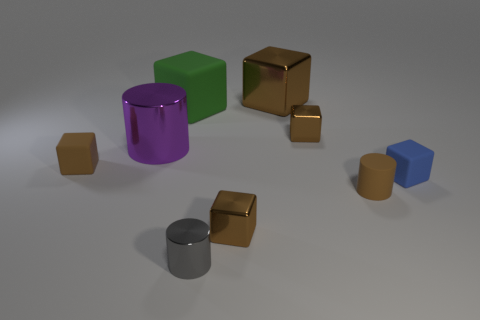Could you describe the lighting in the scene? The lighting in the scene appears to be soft and diffuse, with gentle shadows cast by the objects indicating a light source that is not overly harsh or direct. This creates a subtle ambiance in the image. 